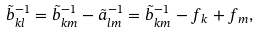<formula> <loc_0><loc_0><loc_500><loc_500>\tilde { b } _ { k l } ^ { - 1 } = \tilde { b } _ { k m } ^ { - 1 } - \tilde { a } _ { l m } ^ { - 1 } = \tilde { b } _ { k m } ^ { - 1 } - f _ { k } + f _ { m } ,</formula> 